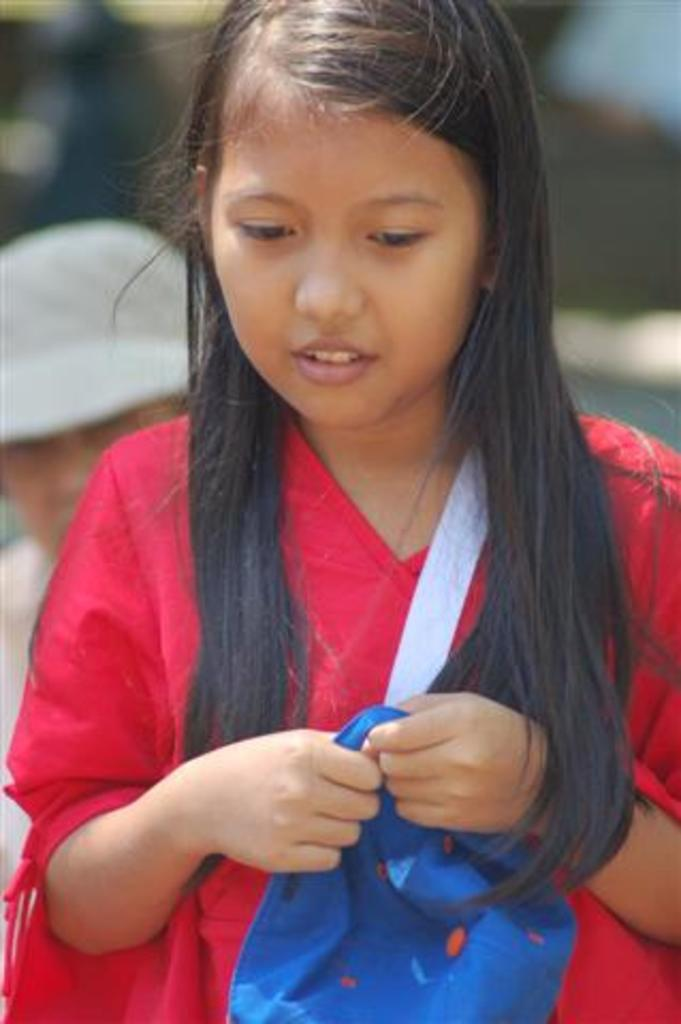Who is the main subject in the image? There is a girl in the image. What is the girl doing in the image? The girl is standing in the image. What is the girl holding in her hands? The girl is holding a bag in her hands. Can you describe the background of the image? There is a person in the background of the image. What type of hole can be seen in the girl's head in the image? There is no hole visible in the girl's head in the image. 